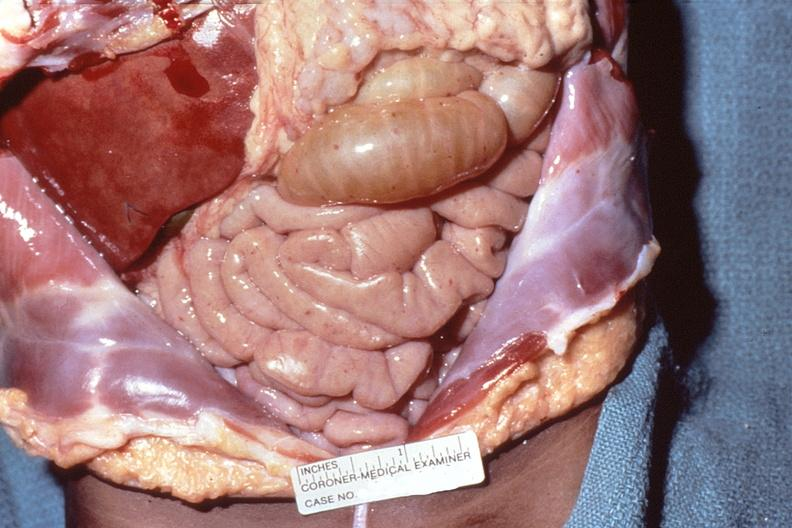what is present?
Answer the question using a single word or phrase. Abdomen 